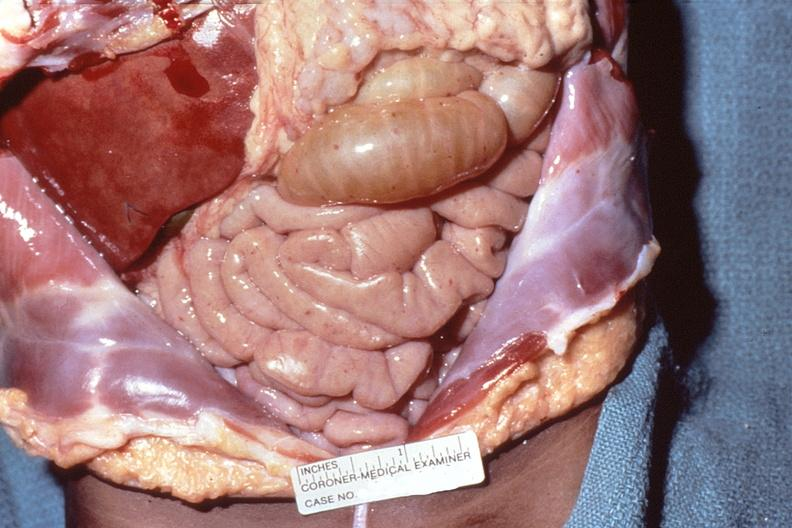what is present?
Answer the question using a single word or phrase. Abdomen 